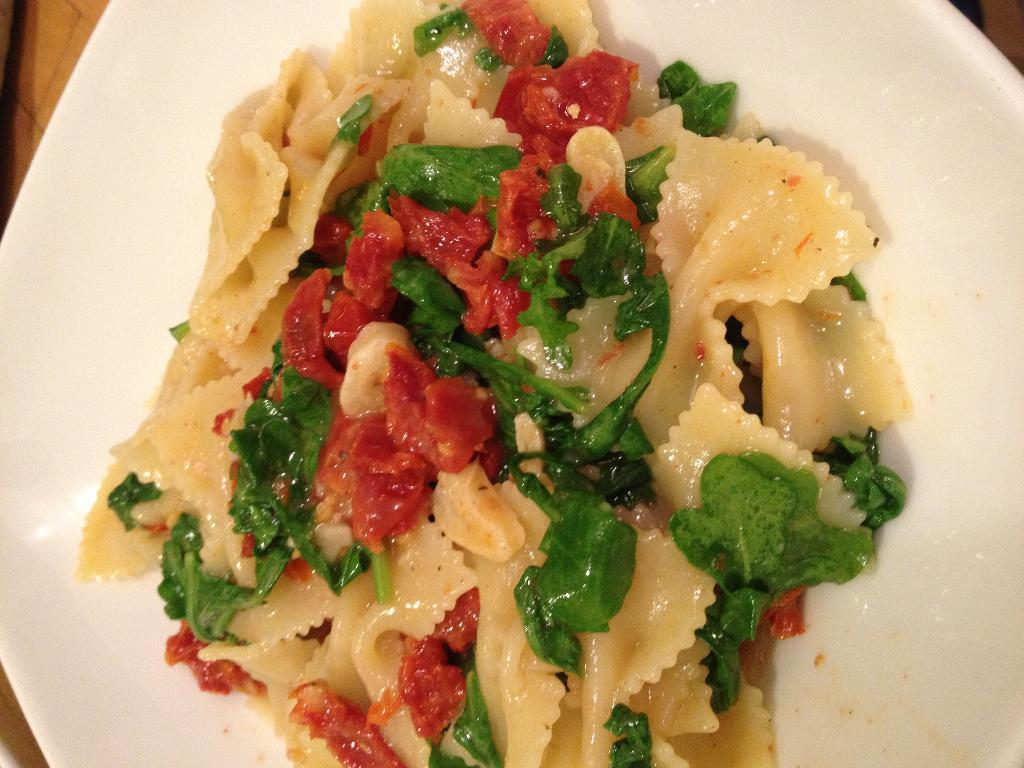What is on the plate in the image? There is a food item on a plate in the image. What color is the plate? The plate is white. What colors can be seen in the food item? The food has red, green, and cream colors. How many passengers are sitting on the tongue in the image? There is no tongue or passengers present in the image. 